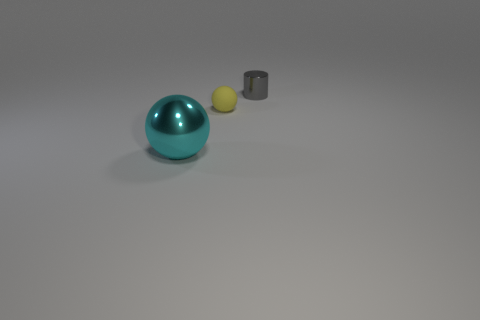Is the shiny cylinder the same color as the small rubber sphere?
Your response must be concise. No. Are there any tiny cylinders in front of the metallic thing on the right side of the big cyan metal object?
Give a very brief answer. No. What number of objects are either tiny objects on the left side of the metallic cylinder or objects behind the cyan ball?
Offer a terse response. 2. What number of things are large yellow metallic balls or tiny things in front of the small gray object?
Make the answer very short. 1. How big is the ball that is to the left of the ball right of the metallic object that is in front of the tiny gray cylinder?
Offer a very short reply. Large. There is a gray thing that is the same size as the rubber sphere; what material is it?
Your answer should be compact. Metal. Are there any other things that have the same size as the rubber thing?
Your answer should be very brief. Yes. There is a shiny thing on the left side of the gray metal thing; is its size the same as the yellow ball?
Offer a terse response. No. What is the shape of the object that is behind the large cyan ball and in front of the gray shiny object?
Ensure brevity in your answer.  Sphere. Is the number of spheres in front of the matte object greater than the number of small yellow cubes?
Give a very brief answer. Yes. 